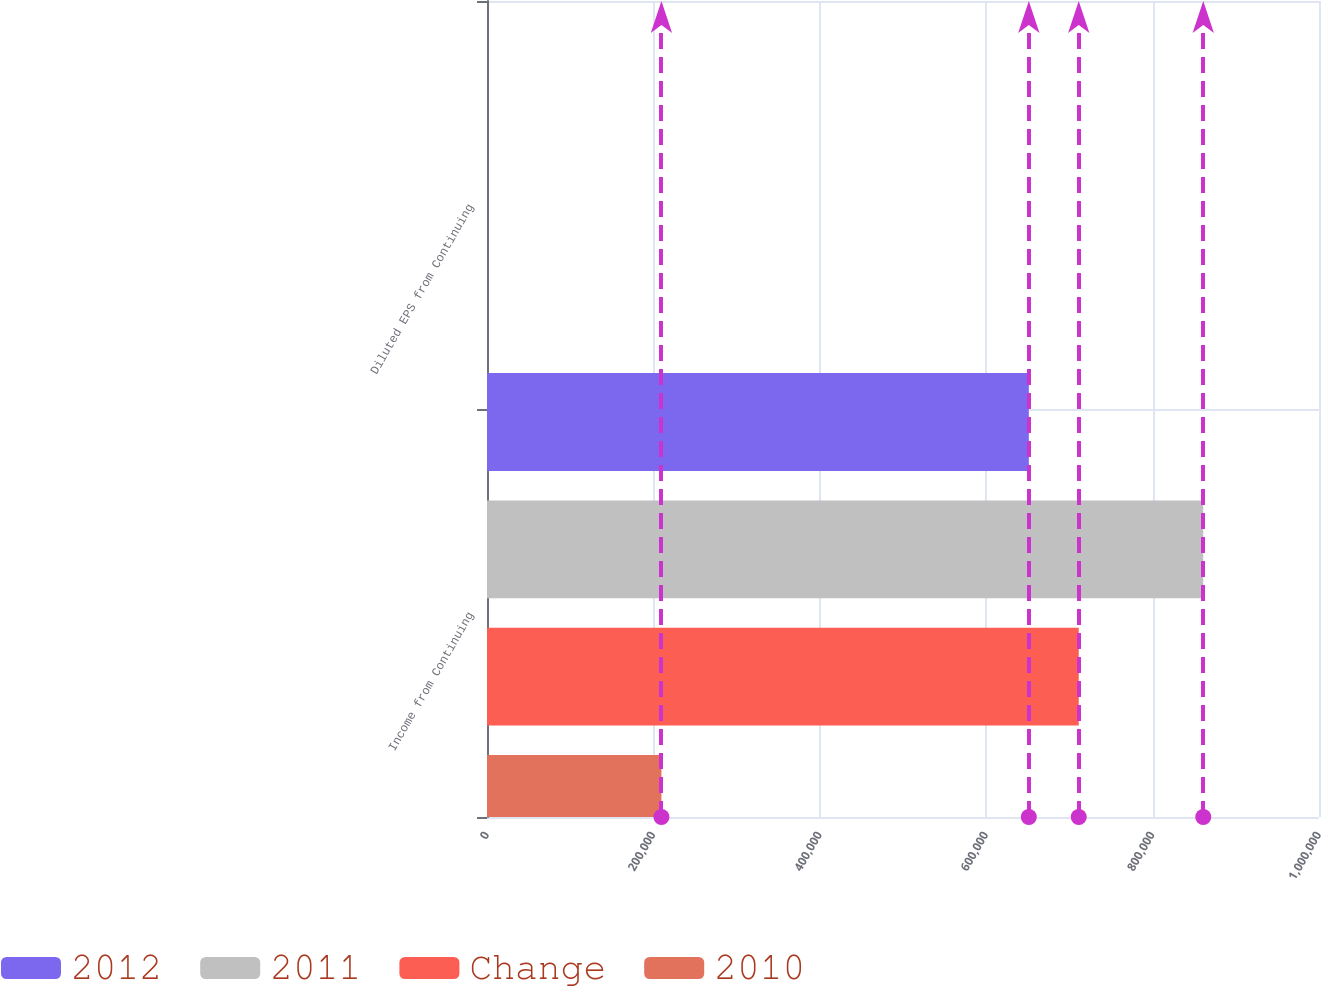Convert chart. <chart><loc_0><loc_0><loc_500><loc_500><stacked_bar_chart><ecel><fcel>Income from Continuing<fcel>Diluted EPS from Continuing<nl><fcel>2012<fcel>651236<fcel>2.13<nl><fcel>2011<fcel>860894<fcel>2.79<nl><fcel>Change<fcel>711225<fcel>2.33<nl><fcel>2010<fcel>209658<fcel>0.66<nl></chart> 